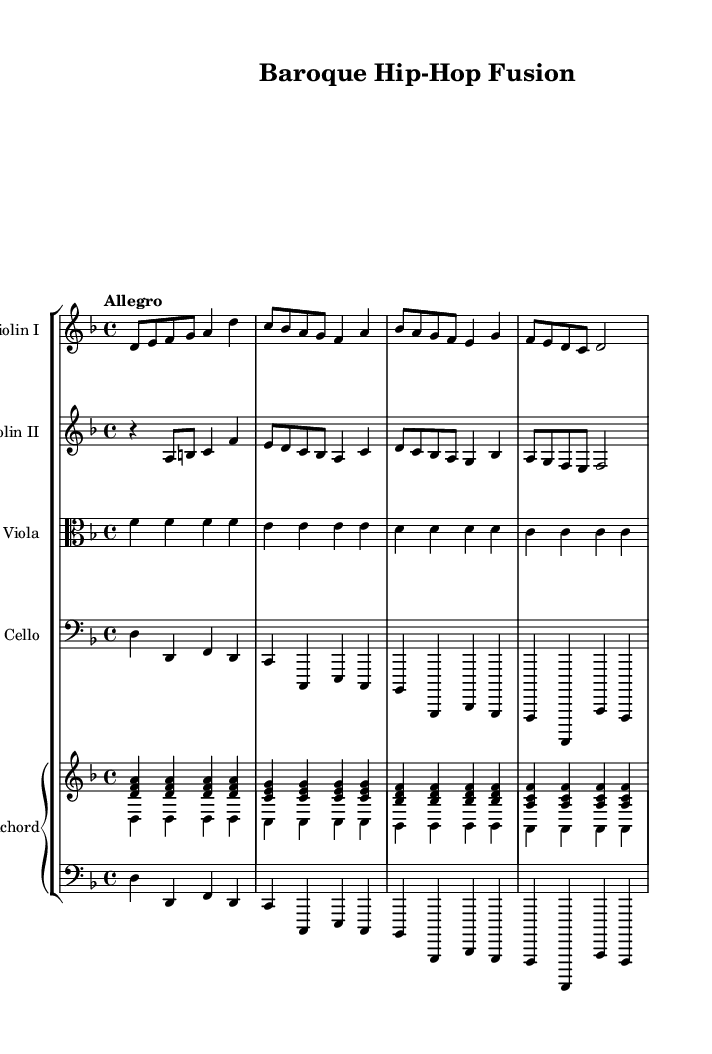What is the key signature of this music? The key signature is indicated by the sharp signs, and in this case, it indicates D minor. The presence of one flat (B flat) in the key of D minor confirms this.
Answer: D minor What is the time signature of this piece? The time signature is displayed at the beginning of the staff, which in this case is 4/4. This indicates that there are four beats per measure and a quarter note receives one beat.
Answer: 4/4 What is the tempo marking for this piece? The tempo marking is found just above the start of the music and simply states "Allegro," which indicates a fast, lively tempo.
Answer: Allegro How many instruments are featured in this orchestral piece? By counting the distinct staves in the score, we see that there are four strings (two violins, viola, cello) and a harpsichord (including both upper and lower parts). This totals to five instruments.
Answer: Five Which instruments play the main melodic lines? The main melodic lines are typically played by the violins, as they are positioned at the top of the staff group and often carry the principal themes in Baroque music.
Answer: Violins What kind of musical techniques might be inspiring for sampling from this piece? The intricate counterpoint, especially with the layering of the violin and the harmonic support from the cello and harpsichord, is a characteristic of Baroque music that offers rich textures for sampling.
Answer: Counterpoint Which instrument provides harmonic support? The instrument that typically provides harmonic support in this orchestral piece is the harpsichord, which plays chords and fills in the harmonic structure throughout the piece.
Answer: Harpsichord 